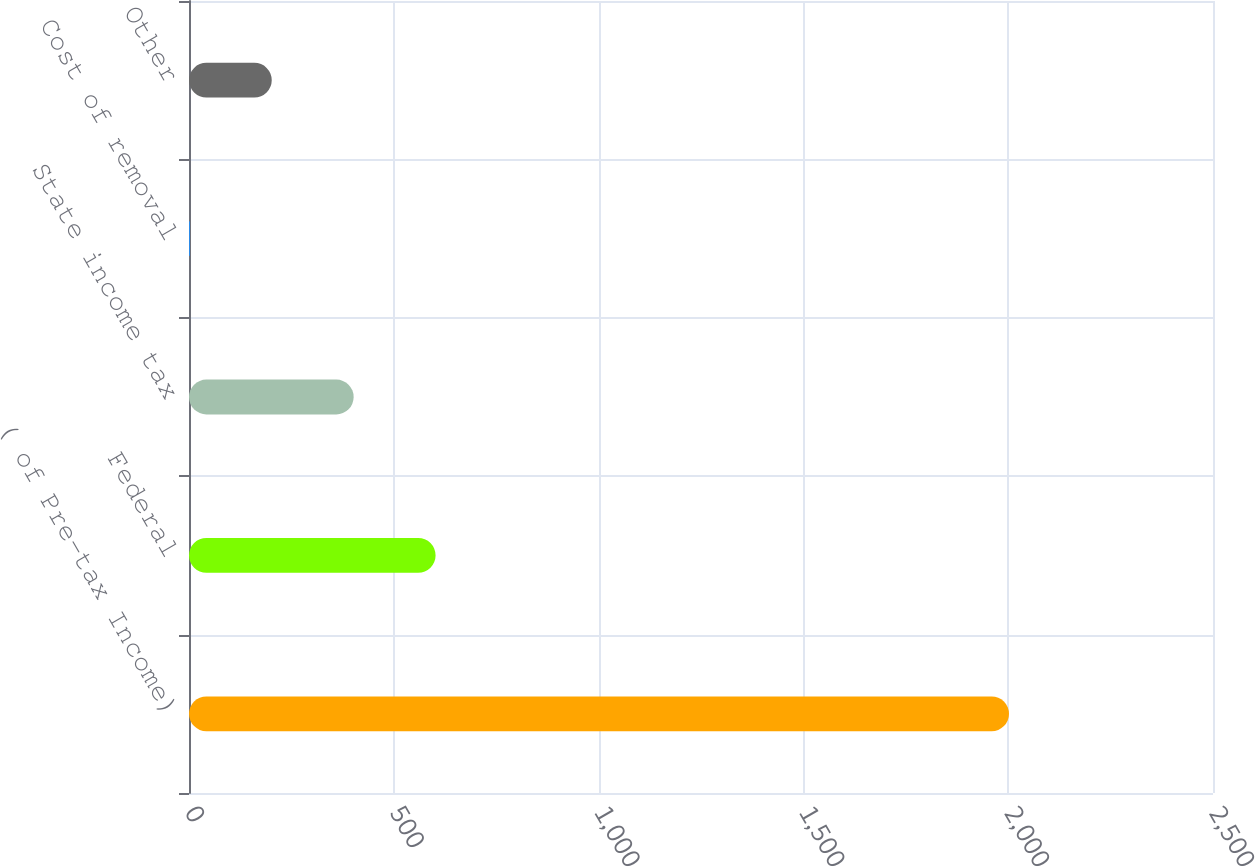Convert chart to OTSL. <chart><loc_0><loc_0><loc_500><loc_500><bar_chart><fcel>( of Pre-tax Income)<fcel>Federal<fcel>State income tax<fcel>Cost of removal<fcel>Other<nl><fcel>2002<fcel>602<fcel>402<fcel>2<fcel>202<nl></chart> 